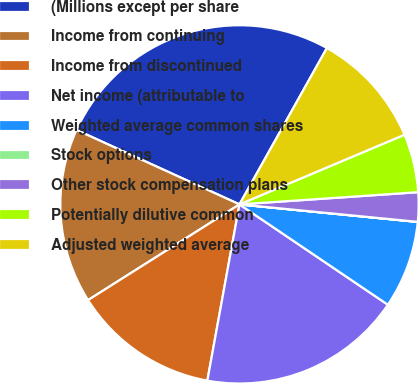<chart> <loc_0><loc_0><loc_500><loc_500><pie_chart><fcel>(Millions except per share<fcel>Income from continuing<fcel>Income from discontinued<fcel>Net income (attributable to<fcel>Weighted average common shares<fcel>Stock options<fcel>Other stock compensation plans<fcel>Potentially dilutive common<fcel>Adjusted weighted average<nl><fcel>26.3%<fcel>15.79%<fcel>13.16%<fcel>18.41%<fcel>7.9%<fcel>0.01%<fcel>2.64%<fcel>5.27%<fcel>10.53%<nl></chart> 